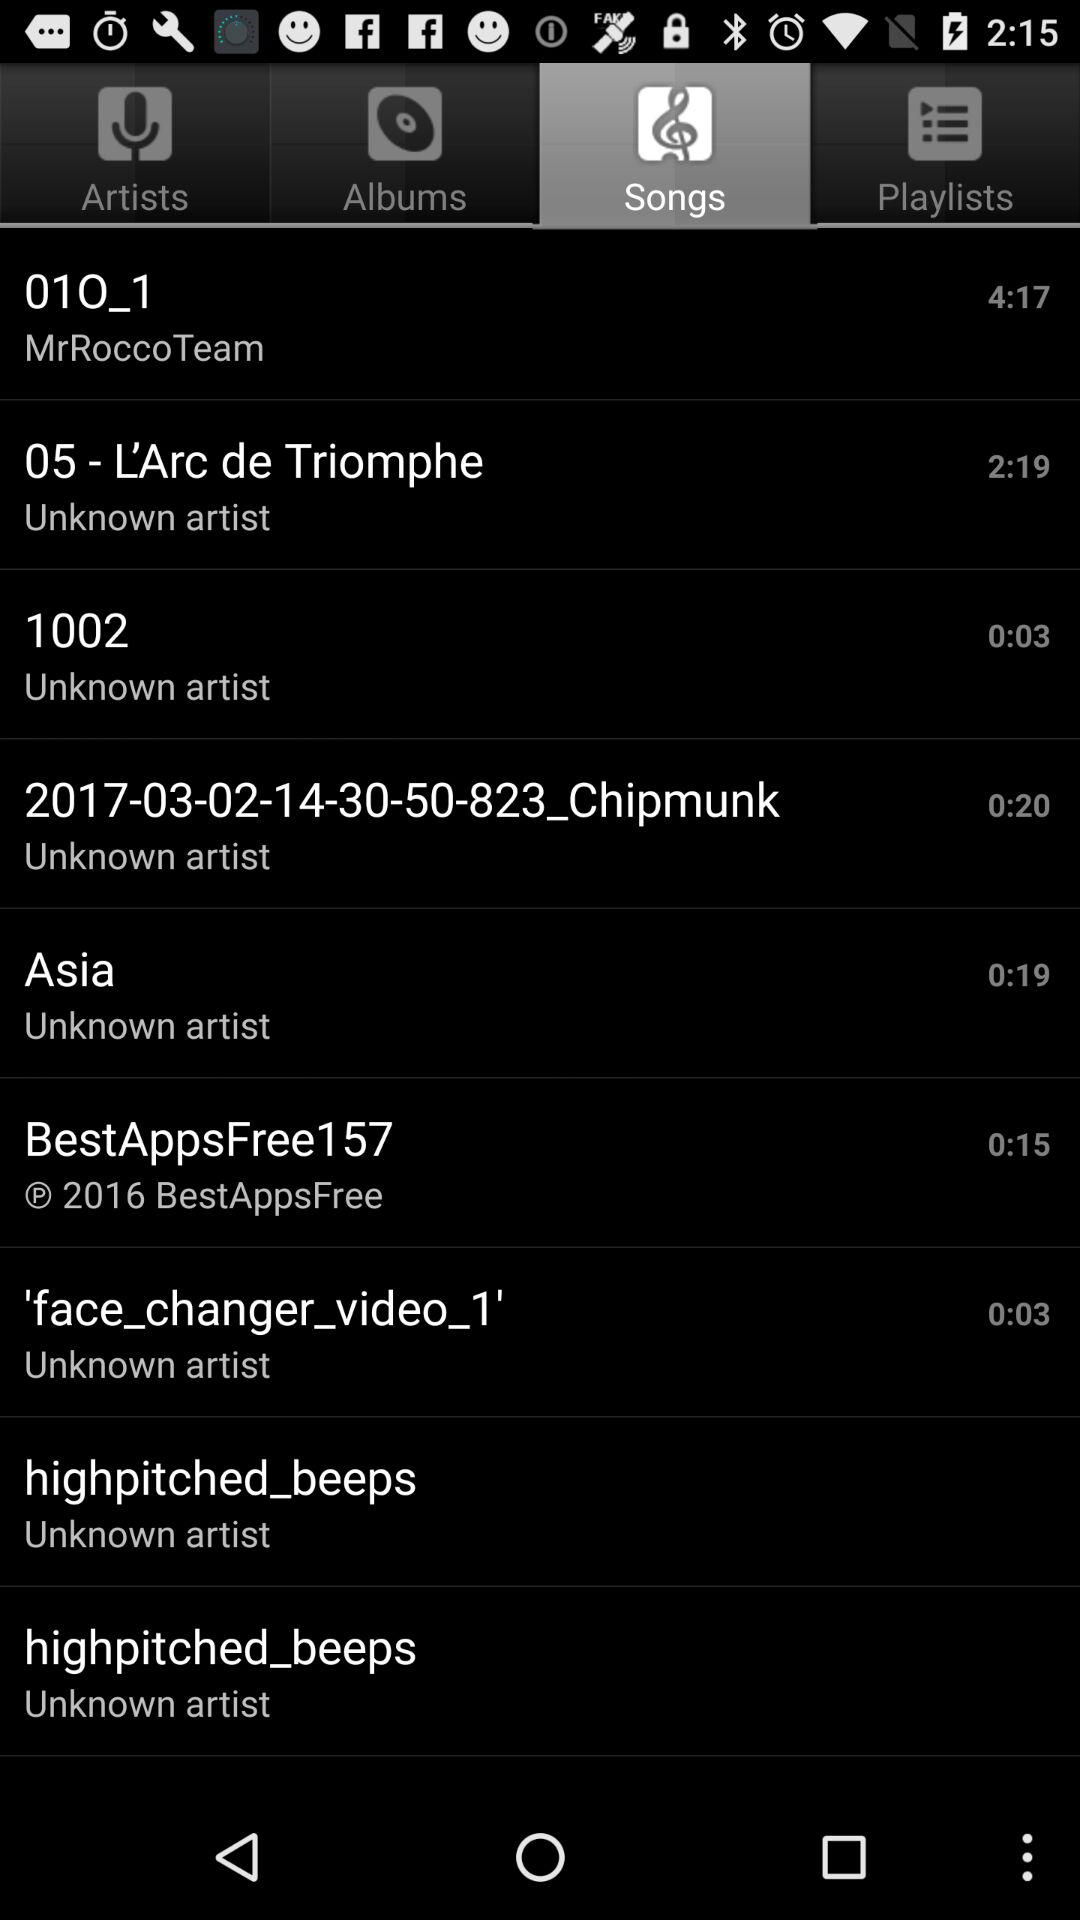What is the time duration of the song Asia? The time duration is 19 seconds. 